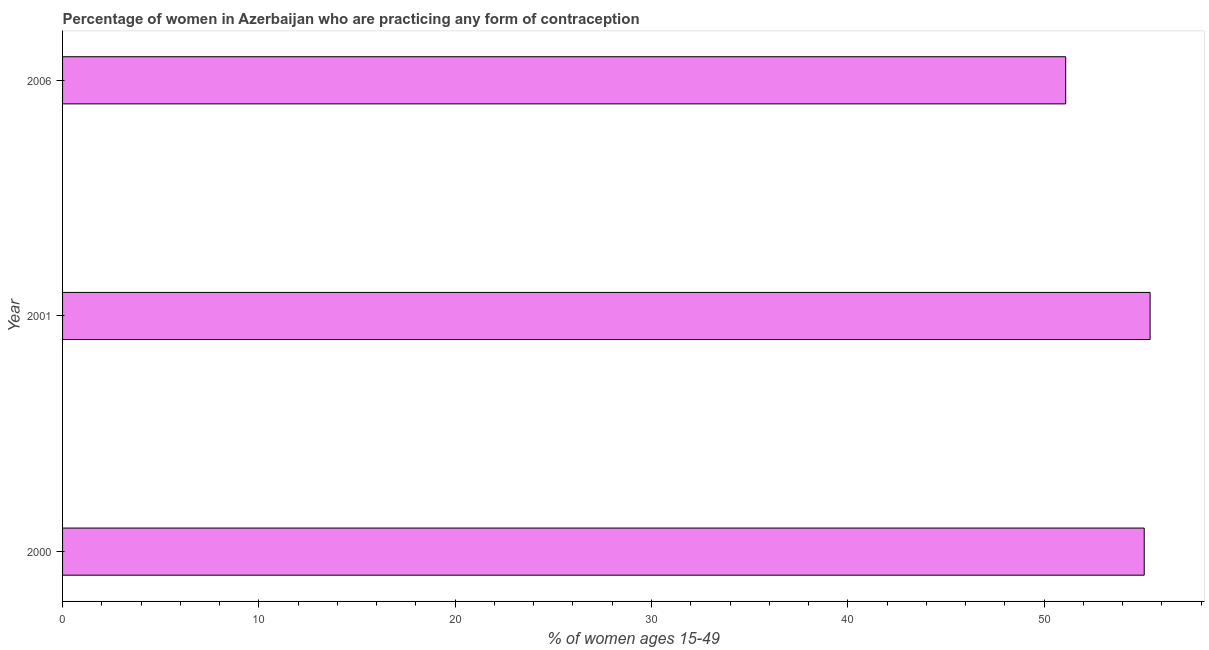Does the graph contain any zero values?
Offer a very short reply. No. What is the title of the graph?
Provide a short and direct response. Percentage of women in Azerbaijan who are practicing any form of contraception. What is the label or title of the X-axis?
Offer a very short reply. % of women ages 15-49. What is the label or title of the Y-axis?
Ensure brevity in your answer.  Year. What is the contraceptive prevalence in 2006?
Offer a very short reply. 51.1. Across all years, what is the maximum contraceptive prevalence?
Keep it short and to the point. 55.4. Across all years, what is the minimum contraceptive prevalence?
Provide a short and direct response. 51.1. In which year was the contraceptive prevalence maximum?
Offer a very short reply. 2001. What is the sum of the contraceptive prevalence?
Keep it short and to the point. 161.6. What is the average contraceptive prevalence per year?
Your response must be concise. 53.87. What is the median contraceptive prevalence?
Your answer should be compact. 55.1. What is the ratio of the contraceptive prevalence in 2001 to that in 2006?
Offer a terse response. 1.08. Is the difference between the contraceptive prevalence in 2000 and 2001 greater than the difference between any two years?
Keep it short and to the point. No. What is the difference between the highest and the lowest contraceptive prevalence?
Provide a short and direct response. 4.3. In how many years, is the contraceptive prevalence greater than the average contraceptive prevalence taken over all years?
Give a very brief answer. 2. How many bars are there?
Your answer should be very brief. 3. Are the values on the major ticks of X-axis written in scientific E-notation?
Give a very brief answer. No. What is the % of women ages 15-49 of 2000?
Offer a terse response. 55.1. What is the % of women ages 15-49 in 2001?
Keep it short and to the point. 55.4. What is the % of women ages 15-49 of 2006?
Your answer should be very brief. 51.1. What is the difference between the % of women ages 15-49 in 2000 and 2006?
Keep it short and to the point. 4. What is the difference between the % of women ages 15-49 in 2001 and 2006?
Offer a terse response. 4.3. What is the ratio of the % of women ages 15-49 in 2000 to that in 2001?
Your response must be concise. 0.99. What is the ratio of the % of women ages 15-49 in 2000 to that in 2006?
Your answer should be very brief. 1.08. What is the ratio of the % of women ages 15-49 in 2001 to that in 2006?
Make the answer very short. 1.08. 